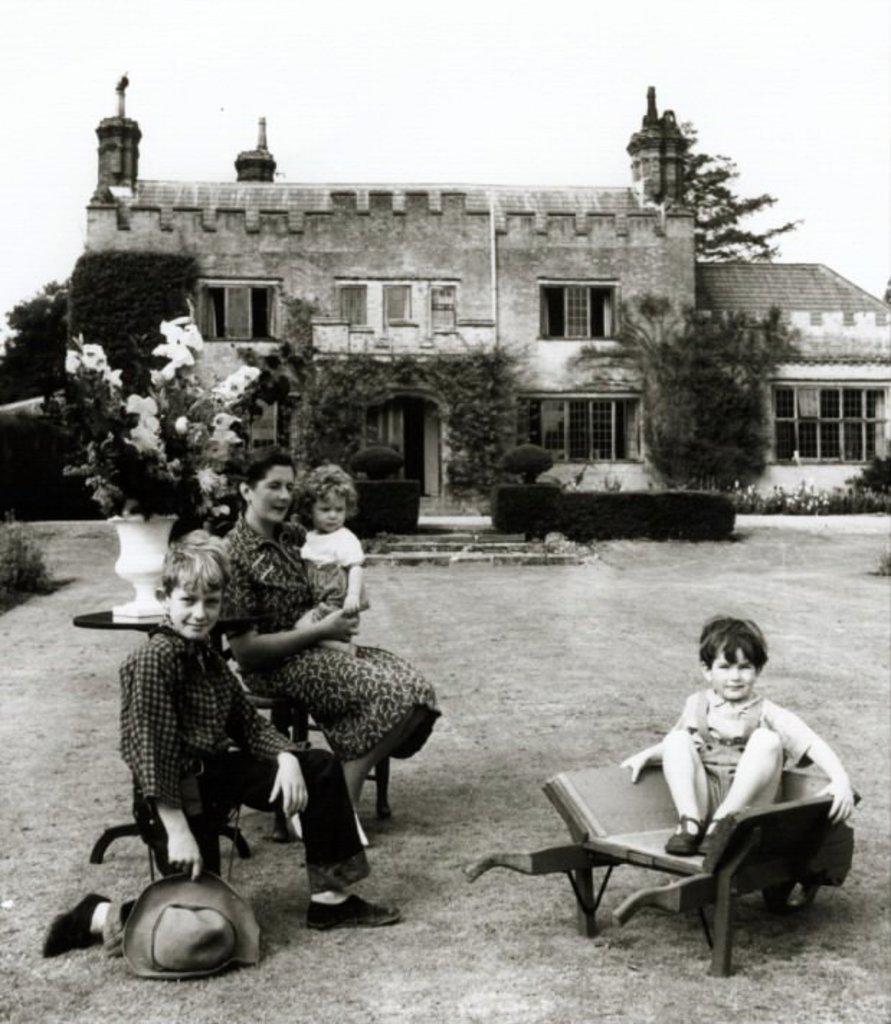Could you give a brief overview of what you see in this image? It is the black and white image in which there is a woman sitting on the chair by holding a kid. Beside her there is a boy who is kneeling on the ground by holding the cap. On the right side there is a kid sitting in the chair. In the background there is a building with the windows and garden in front of it. At the top there is sky. On the left side there is a flower pot on the table. 